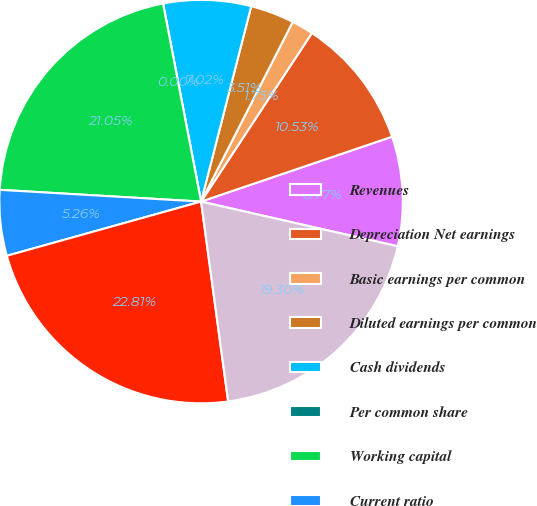Convert chart to OTSL. <chart><loc_0><loc_0><loc_500><loc_500><pie_chart><fcel>Revenues<fcel>Depreciation Net earnings<fcel>Basic earnings per common<fcel>Diluted earnings per common<fcel>Cash dividends<fcel>Per common share<fcel>Working capital<fcel>Current ratio<fcel>Inventories<fcel>Net property plant and<nl><fcel>8.77%<fcel>10.53%<fcel>1.75%<fcel>3.51%<fcel>7.02%<fcel>0.0%<fcel>21.05%<fcel>5.26%<fcel>22.81%<fcel>19.3%<nl></chart> 